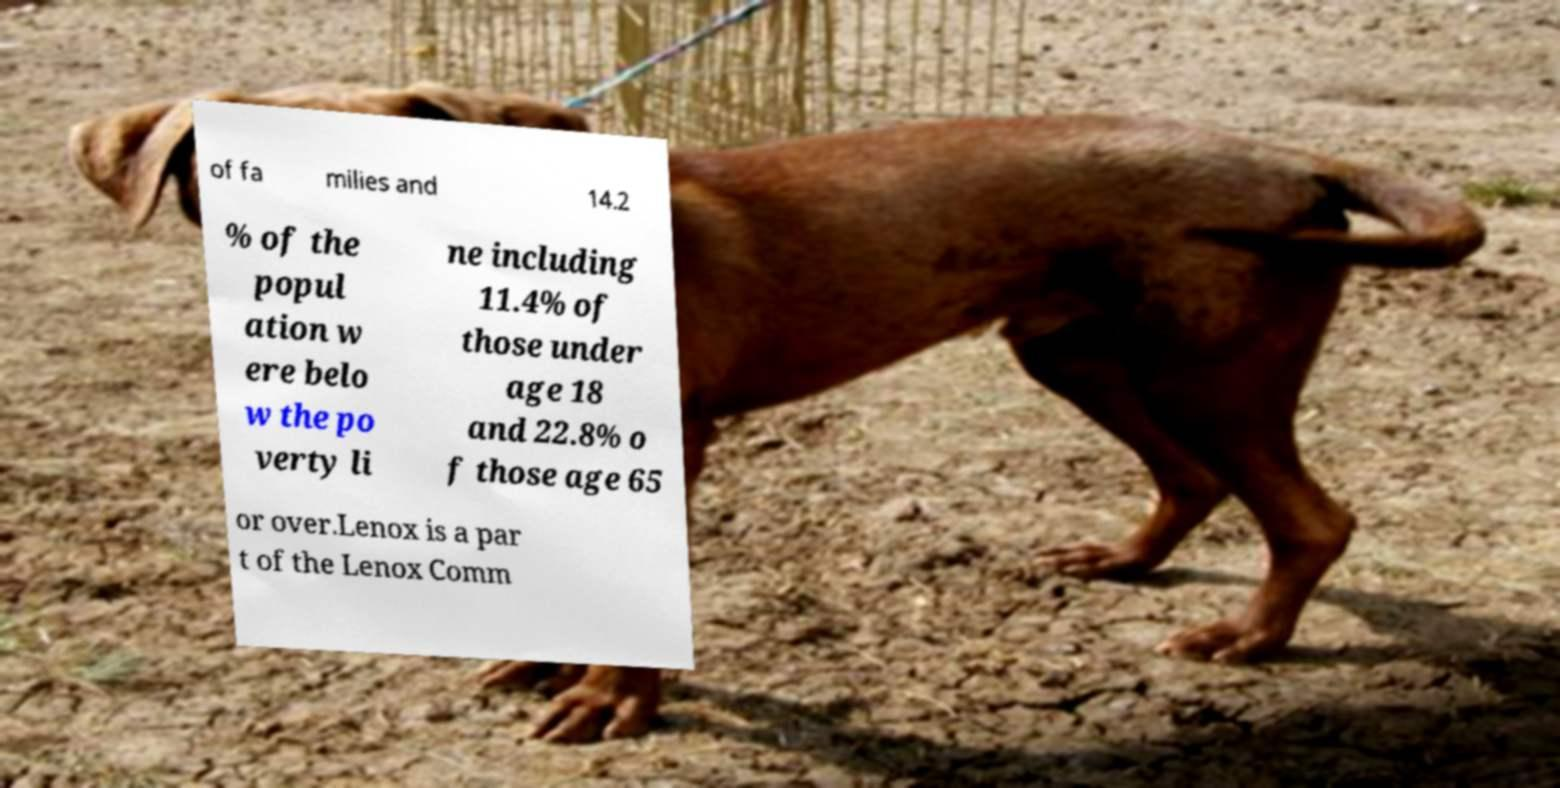There's text embedded in this image that I need extracted. Can you transcribe it verbatim? of fa milies and 14.2 % of the popul ation w ere belo w the po verty li ne including 11.4% of those under age 18 and 22.8% o f those age 65 or over.Lenox is a par t of the Lenox Comm 